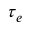<formula> <loc_0><loc_0><loc_500><loc_500>\tau _ { e }</formula> 